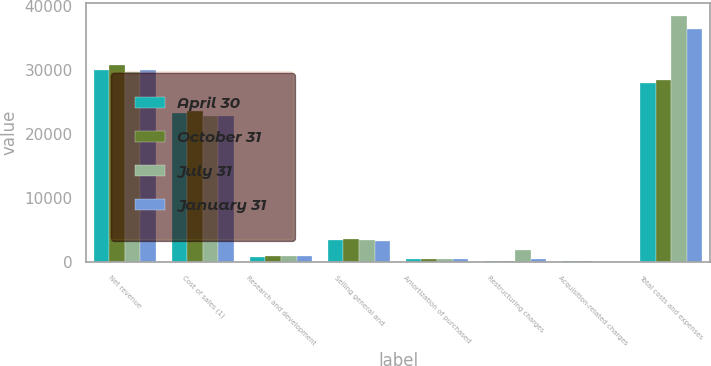<chart> <loc_0><loc_0><loc_500><loc_500><stacked_bar_chart><ecel><fcel>Net revenue<fcel>Cost of sales (1)<fcel>Research and development<fcel>Selling general and<fcel>Amortization of purchased<fcel>Restructuring charges<fcel>Acquisition-related charges<fcel>Total costs and expenses<nl><fcel>April 30<fcel>30036<fcel>23313<fcel>786<fcel>3367<fcel>466<fcel>40<fcel>22<fcel>27994<nl><fcel>October 31<fcel>30693<fcel>23541<fcel>850<fcel>3540<fcel>470<fcel>53<fcel>17<fcel>28471<nl><fcel>July 31<fcel>29669<fcel>22820<fcel>854<fcel>3366<fcel>476<fcel>1795<fcel>3<fcel>38502<nl><fcel>January 31<fcel>29959<fcel>22711<fcel>909<fcel>3227<fcel>372<fcel>378<fcel>3<fcel>36447<nl></chart> 